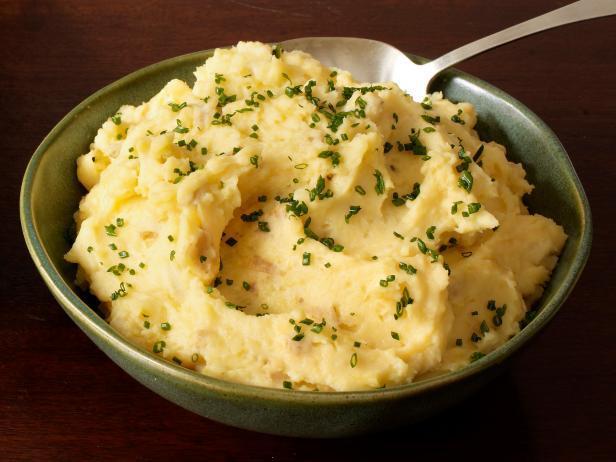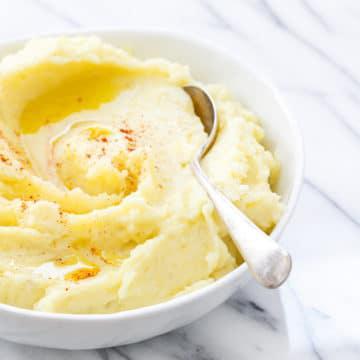The first image is the image on the left, the second image is the image on the right. For the images shown, is this caption "Each image shows one round bowl with potatoes and some type of silver utensil in it, and one image features a white bowl with a spoon in mashed potatoes." true? Answer yes or no. Yes. The first image is the image on the left, the second image is the image on the right. Assess this claim about the two images: "The left and right image contains the same number of fully mashed potatoes bowls with spoons.". Correct or not? Answer yes or no. Yes. 